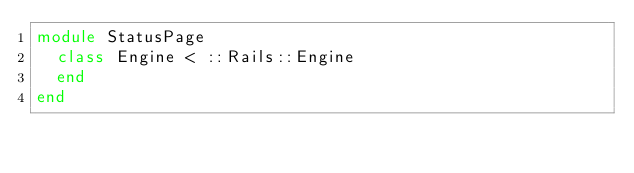<code> <loc_0><loc_0><loc_500><loc_500><_Ruby_>module StatusPage
  class Engine < ::Rails::Engine
  end
end
</code> 